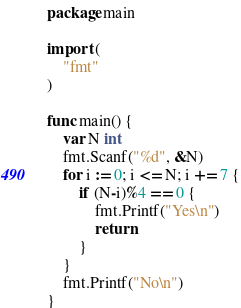Convert code to text. <code><loc_0><loc_0><loc_500><loc_500><_Go_>package main

import (
	"fmt"
)

func main() {
	var N int
	fmt.Scanf("%d", &N)
	for i := 0; i <= N; i += 7 {
		if (N-i)%4 == 0 {
			fmt.Printf("Yes\n")
			return
		}
	}
	fmt.Printf("No\n")
}
</code> 